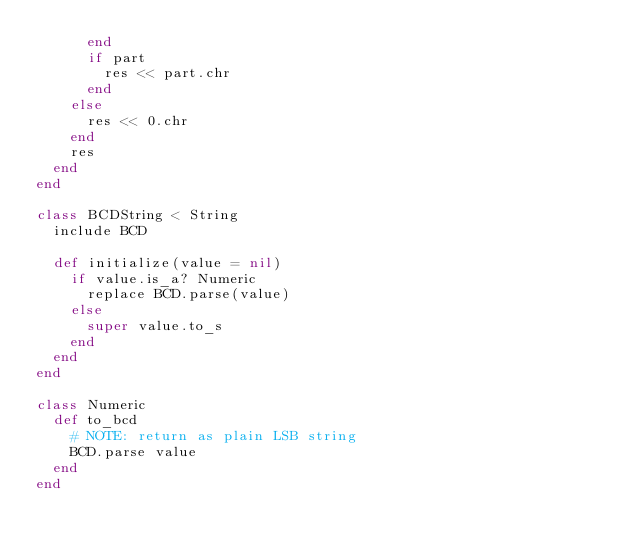<code> <loc_0><loc_0><loc_500><loc_500><_Ruby_>      end
      if part
        res << part.chr
      end
    else
      res << 0.chr
    end
    res
  end
end

class BCDString < String
  include BCD

  def initialize(value = nil)
    if value.is_a? Numeric
      replace BCD.parse(value)
    else
      super value.to_s
    end
  end
end

class Numeric
  def to_bcd
    # NOTE: return as plain LSB string
    BCD.parse value
  end
end
</code> 